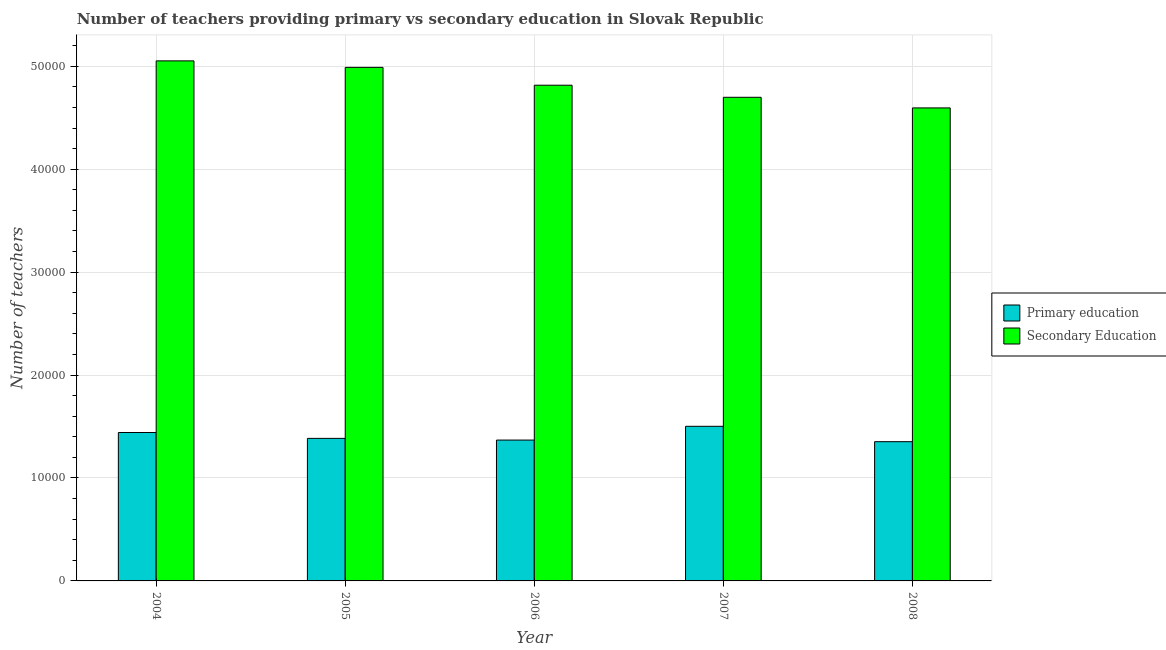How many groups of bars are there?
Your answer should be compact. 5. Are the number of bars on each tick of the X-axis equal?
Your answer should be very brief. Yes. How many bars are there on the 5th tick from the left?
Make the answer very short. 2. How many bars are there on the 2nd tick from the right?
Provide a succinct answer. 2. What is the number of secondary teachers in 2007?
Your response must be concise. 4.70e+04. Across all years, what is the maximum number of primary teachers?
Your answer should be compact. 1.50e+04. Across all years, what is the minimum number of secondary teachers?
Keep it short and to the point. 4.60e+04. In which year was the number of secondary teachers maximum?
Provide a short and direct response. 2004. What is the total number of primary teachers in the graph?
Your answer should be very brief. 7.05e+04. What is the difference between the number of primary teachers in 2006 and that in 2007?
Provide a short and direct response. -1338. What is the difference between the number of primary teachers in 2008 and the number of secondary teachers in 2006?
Provide a short and direct response. -155. What is the average number of secondary teachers per year?
Provide a short and direct response. 4.83e+04. In the year 2008, what is the difference between the number of secondary teachers and number of primary teachers?
Provide a short and direct response. 0. What is the ratio of the number of secondary teachers in 2004 to that in 2005?
Your answer should be compact. 1.01. Is the difference between the number of secondary teachers in 2005 and 2006 greater than the difference between the number of primary teachers in 2005 and 2006?
Offer a terse response. No. What is the difference between the highest and the second highest number of primary teachers?
Your response must be concise. 602. What is the difference between the highest and the lowest number of secondary teachers?
Ensure brevity in your answer.  4570. Is the sum of the number of primary teachers in 2005 and 2008 greater than the maximum number of secondary teachers across all years?
Ensure brevity in your answer.  Yes. What does the 2nd bar from the left in 2007 represents?
Keep it short and to the point. Secondary Education. What does the 2nd bar from the right in 2007 represents?
Provide a short and direct response. Primary education. How many bars are there?
Make the answer very short. 10. How many years are there in the graph?
Give a very brief answer. 5. Are the values on the major ticks of Y-axis written in scientific E-notation?
Your response must be concise. No. Where does the legend appear in the graph?
Make the answer very short. Center right. How are the legend labels stacked?
Your answer should be compact. Vertical. What is the title of the graph?
Offer a very short reply. Number of teachers providing primary vs secondary education in Slovak Republic. Does "Foreign Liabilities" appear as one of the legend labels in the graph?
Offer a terse response. No. What is the label or title of the Y-axis?
Give a very brief answer. Number of teachers. What is the Number of teachers in Primary education in 2004?
Give a very brief answer. 1.44e+04. What is the Number of teachers in Secondary Education in 2004?
Ensure brevity in your answer.  5.05e+04. What is the Number of teachers in Primary education in 2005?
Keep it short and to the point. 1.38e+04. What is the Number of teachers of Secondary Education in 2005?
Keep it short and to the point. 4.99e+04. What is the Number of teachers of Primary education in 2006?
Offer a very short reply. 1.37e+04. What is the Number of teachers of Secondary Education in 2006?
Offer a terse response. 4.82e+04. What is the Number of teachers in Primary education in 2007?
Provide a succinct answer. 1.50e+04. What is the Number of teachers in Secondary Education in 2007?
Make the answer very short. 4.70e+04. What is the Number of teachers in Primary education in 2008?
Keep it short and to the point. 1.35e+04. What is the Number of teachers of Secondary Education in 2008?
Keep it short and to the point. 4.60e+04. Across all years, what is the maximum Number of teachers in Primary education?
Offer a terse response. 1.50e+04. Across all years, what is the maximum Number of teachers of Secondary Education?
Your answer should be compact. 5.05e+04. Across all years, what is the minimum Number of teachers of Primary education?
Your answer should be compact. 1.35e+04. Across all years, what is the minimum Number of teachers of Secondary Education?
Provide a succinct answer. 4.60e+04. What is the total Number of teachers in Primary education in the graph?
Ensure brevity in your answer.  7.05e+04. What is the total Number of teachers of Secondary Education in the graph?
Offer a terse response. 2.42e+05. What is the difference between the Number of teachers in Primary education in 2004 and that in 2005?
Your answer should be very brief. 571. What is the difference between the Number of teachers in Secondary Education in 2004 and that in 2005?
Offer a very short reply. 630. What is the difference between the Number of teachers of Primary education in 2004 and that in 2006?
Your answer should be very brief. 736. What is the difference between the Number of teachers of Secondary Education in 2004 and that in 2006?
Provide a short and direct response. 2364. What is the difference between the Number of teachers of Primary education in 2004 and that in 2007?
Keep it short and to the point. -602. What is the difference between the Number of teachers in Secondary Education in 2004 and that in 2007?
Keep it short and to the point. 3537. What is the difference between the Number of teachers in Primary education in 2004 and that in 2008?
Provide a succinct answer. 891. What is the difference between the Number of teachers in Secondary Education in 2004 and that in 2008?
Ensure brevity in your answer.  4570. What is the difference between the Number of teachers in Primary education in 2005 and that in 2006?
Your response must be concise. 165. What is the difference between the Number of teachers of Secondary Education in 2005 and that in 2006?
Your answer should be very brief. 1734. What is the difference between the Number of teachers of Primary education in 2005 and that in 2007?
Keep it short and to the point. -1173. What is the difference between the Number of teachers of Secondary Education in 2005 and that in 2007?
Offer a terse response. 2907. What is the difference between the Number of teachers in Primary education in 2005 and that in 2008?
Offer a terse response. 320. What is the difference between the Number of teachers of Secondary Education in 2005 and that in 2008?
Offer a very short reply. 3940. What is the difference between the Number of teachers in Primary education in 2006 and that in 2007?
Provide a succinct answer. -1338. What is the difference between the Number of teachers of Secondary Education in 2006 and that in 2007?
Ensure brevity in your answer.  1173. What is the difference between the Number of teachers of Primary education in 2006 and that in 2008?
Give a very brief answer. 155. What is the difference between the Number of teachers in Secondary Education in 2006 and that in 2008?
Make the answer very short. 2206. What is the difference between the Number of teachers in Primary education in 2007 and that in 2008?
Give a very brief answer. 1493. What is the difference between the Number of teachers of Secondary Education in 2007 and that in 2008?
Your response must be concise. 1033. What is the difference between the Number of teachers of Primary education in 2004 and the Number of teachers of Secondary Education in 2005?
Offer a terse response. -3.55e+04. What is the difference between the Number of teachers in Primary education in 2004 and the Number of teachers in Secondary Education in 2006?
Your answer should be very brief. -3.37e+04. What is the difference between the Number of teachers of Primary education in 2004 and the Number of teachers of Secondary Education in 2007?
Your response must be concise. -3.26e+04. What is the difference between the Number of teachers in Primary education in 2004 and the Number of teachers in Secondary Education in 2008?
Ensure brevity in your answer.  -3.15e+04. What is the difference between the Number of teachers in Primary education in 2005 and the Number of teachers in Secondary Education in 2006?
Your response must be concise. -3.43e+04. What is the difference between the Number of teachers of Primary education in 2005 and the Number of teachers of Secondary Education in 2007?
Your answer should be very brief. -3.31e+04. What is the difference between the Number of teachers of Primary education in 2005 and the Number of teachers of Secondary Education in 2008?
Keep it short and to the point. -3.21e+04. What is the difference between the Number of teachers of Primary education in 2006 and the Number of teachers of Secondary Education in 2007?
Offer a very short reply. -3.33e+04. What is the difference between the Number of teachers of Primary education in 2006 and the Number of teachers of Secondary Education in 2008?
Provide a succinct answer. -3.23e+04. What is the difference between the Number of teachers of Primary education in 2007 and the Number of teachers of Secondary Education in 2008?
Make the answer very short. -3.09e+04. What is the average Number of teachers in Primary education per year?
Offer a very short reply. 1.41e+04. What is the average Number of teachers of Secondary Education per year?
Give a very brief answer. 4.83e+04. In the year 2004, what is the difference between the Number of teachers of Primary education and Number of teachers of Secondary Education?
Offer a terse response. -3.61e+04. In the year 2005, what is the difference between the Number of teachers of Primary education and Number of teachers of Secondary Education?
Offer a terse response. -3.60e+04. In the year 2006, what is the difference between the Number of teachers in Primary education and Number of teachers in Secondary Education?
Give a very brief answer. -3.45e+04. In the year 2007, what is the difference between the Number of teachers of Primary education and Number of teachers of Secondary Education?
Provide a short and direct response. -3.20e+04. In the year 2008, what is the difference between the Number of teachers of Primary education and Number of teachers of Secondary Education?
Offer a terse response. -3.24e+04. What is the ratio of the Number of teachers of Primary education in 2004 to that in 2005?
Ensure brevity in your answer.  1.04. What is the ratio of the Number of teachers of Secondary Education in 2004 to that in 2005?
Offer a terse response. 1.01. What is the ratio of the Number of teachers of Primary education in 2004 to that in 2006?
Provide a short and direct response. 1.05. What is the ratio of the Number of teachers in Secondary Education in 2004 to that in 2006?
Give a very brief answer. 1.05. What is the ratio of the Number of teachers in Primary education in 2004 to that in 2007?
Provide a short and direct response. 0.96. What is the ratio of the Number of teachers of Secondary Education in 2004 to that in 2007?
Keep it short and to the point. 1.08. What is the ratio of the Number of teachers in Primary education in 2004 to that in 2008?
Provide a succinct answer. 1.07. What is the ratio of the Number of teachers in Secondary Education in 2004 to that in 2008?
Your answer should be compact. 1.1. What is the ratio of the Number of teachers of Primary education in 2005 to that in 2006?
Give a very brief answer. 1.01. What is the ratio of the Number of teachers in Secondary Education in 2005 to that in 2006?
Provide a short and direct response. 1.04. What is the ratio of the Number of teachers in Primary education in 2005 to that in 2007?
Offer a terse response. 0.92. What is the ratio of the Number of teachers in Secondary Education in 2005 to that in 2007?
Your response must be concise. 1.06. What is the ratio of the Number of teachers of Primary education in 2005 to that in 2008?
Keep it short and to the point. 1.02. What is the ratio of the Number of teachers of Secondary Education in 2005 to that in 2008?
Make the answer very short. 1.09. What is the ratio of the Number of teachers of Primary education in 2006 to that in 2007?
Offer a very short reply. 0.91. What is the ratio of the Number of teachers in Secondary Education in 2006 to that in 2007?
Provide a short and direct response. 1.02. What is the ratio of the Number of teachers in Primary education in 2006 to that in 2008?
Your answer should be compact. 1.01. What is the ratio of the Number of teachers in Secondary Education in 2006 to that in 2008?
Offer a very short reply. 1.05. What is the ratio of the Number of teachers in Primary education in 2007 to that in 2008?
Your response must be concise. 1.11. What is the ratio of the Number of teachers in Secondary Education in 2007 to that in 2008?
Keep it short and to the point. 1.02. What is the difference between the highest and the second highest Number of teachers of Primary education?
Your response must be concise. 602. What is the difference between the highest and the second highest Number of teachers in Secondary Education?
Your response must be concise. 630. What is the difference between the highest and the lowest Number of teachers of Primary education?
Give a very brief answer. 1493. What is the difference between the highest and the lowest Number of teachers in Secondary Education?
Provide a short and direct response. 4570. 